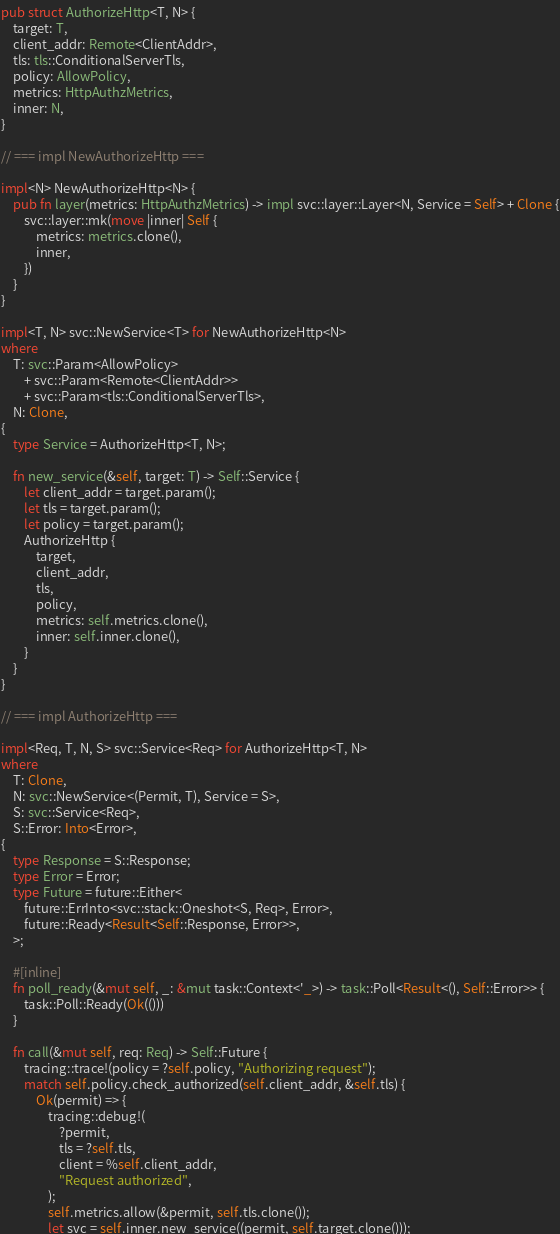Convert code to text. <code><loc_0><loc_0><loc_500><loc_500><_Rust_>pub struct AuthorizeHttp<T, N> {
    target: T,
    client_addr: Remote<ClientAddr>,
    tls: tls::ConditionalServerTls,
    policy: AllowPolicy,
    metrics: HttpAuthzMetrics,
    inner: N,
}

// === impl NewAuthorizeHttp ===

impl<N> NewAuthorizeHttp<N> {
    pub fn layer(metrics: HttpAuthzMetrics) -> impl svc::layer::Layer<N, Service = Self> + Clone {
        svc::layer::mk(move |inner| Self {
            metrics: metrics.clone(),
            inner,
        })
    }
}

impl<T, N> svc::NewService<T> for NewAuthorizeHttp<N>
where
    T: svc::Param<AllowPolicy>
        + svc::Param<Remote<ClientAddr>>
        + svc::Param<tls::ConditionalServerTls>,
    N: Clone,
{
    type Service = AuthorizeHttp<T, N>;

    fn new_service(&self, target: T) -> Self::Service {
        let client_addr = target.param();
        let tls = target.param();
        let policy = target.param();
        AuthorizeHttp {
            target,
            client_addr,
            tls,
            policy,
            metrics: self.metrics.clone(),
            inner: self.inner.clone(),
        }
    }
}

// === impl AuthorizeHttp ===

impl<Req, T, N, S> svc::Service<Req> for AuthorizeHttp<T, N>
where
    T: Clone,
    N: svc::NewService<(Permit, T), Service = S>,
    S: svc::Service<Req>,
    S::Error: Into<Error>,
{
    type Response = S::Response;
    type Error = Error;
    type Future = future::Either<
        future::ErrInto<svc::stack::Oneshot<S, Req>, Error>,
        future::Ready<Result<Self::Response, Error>>,
    >;

    #[inline]
    fn poll_ready(&mut self, _: &mut task::Context<'_>) -> task::Poll<Result<(), Self::Error>> {
        task::Poll::Ready(Ok(()))
    }

    fn call(&mut self, req: Req) -> Self::Future {
        tracing::trace!(policy = ?self.policy, "Authorizing request");
        match self.policy.check_authorized(self.client_addr, &self.tls) {
            Ok(permit) => {
                tracing::debug!(
                    ?permit,
                    tls = ?self.tls,
                    client = %self.client_addr,
                    "Request authorized",
                );
                self.metrics.allow(&permit, self.tls.clone());
                let svc = self.inner.new_service((permit, self.target.clone()));</code> 